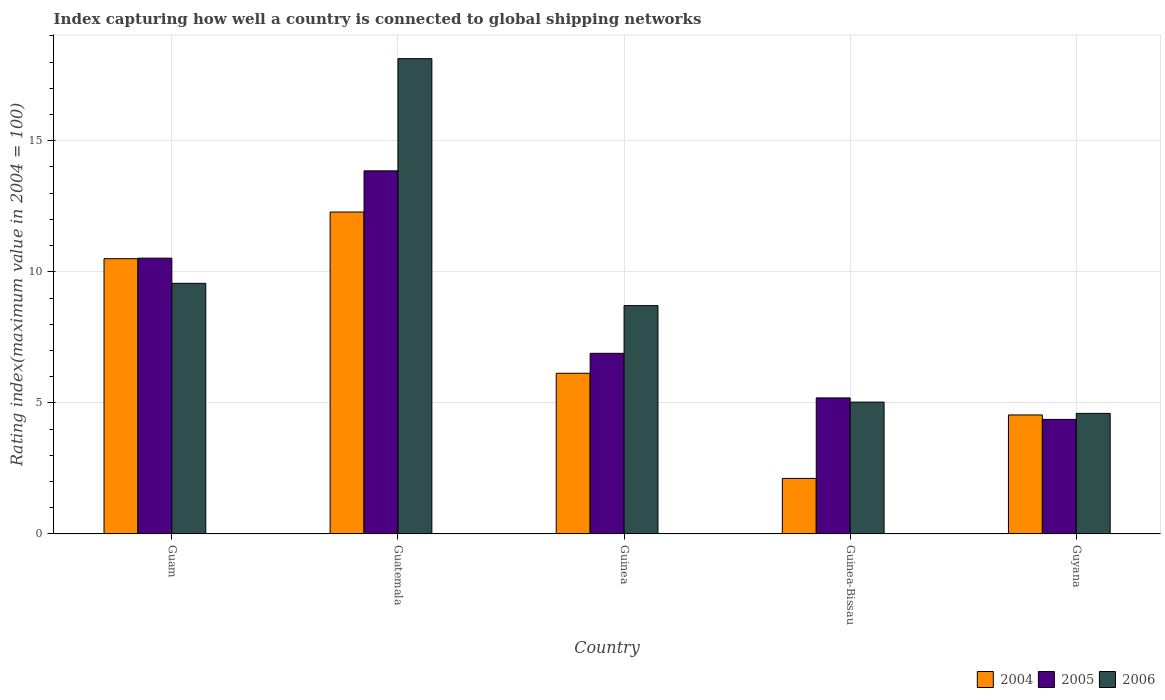How many groups of bars are there?
Keep it short and to the point. 5. How many bars are there on the 5th tick from the left?
Offer a terse response. 3. How many bars are there on the 5th tick from the right?
Provide a succinct answer. 3. What is the label of the 2nd group of bars from the left?
Offer a very short reply. Guatemala. What is the rating index in 2005 in Guam?
Keep it short and to the point. 10.52. Across all countries, what is the maximum rating index in 2005?
Offer a terse response. 13.85. Across all countries, what is the minimum rating index in 2004?
Ensure brevity in your answer.  2.12. In which country was the rating index in 2004 maximum?
Provide a succinct answer. Guatemala. In which country was the rating index in 2005 minimum?
Your response must be concise. Guyana. What is the total rating index in 2004 in the graph?
Your response must be concise. 35.57. What is the difference between the rating index in 2004 in Guatemala and that in Guinea-Bissau?
Ensure brevity in your answer.  10.16. What is the difference between the rating index in 2004 in Guam and the rating index in 2006 in Guyana?
Your answer should be very brief. 5.9. What is the average rating index in 2006 per country?
Ensure brevity in your answer.  9.21. What is the difference between the rating index of/in 2004 and rating index of/in 2005 in Guinea?
Keep it short and to the point. -0.76. In how many countries, is the rating index in 2006 greater than 8?
Keep it short and to the point. 3. What is the ratio of the rating index in 2005 in Guam to that in Guinea-Bissau?
Offer a very short reply. 2.03. What is the difference between the highest and the second highest rating index in 2006?
Your response must be concise. -0.85. What is the difference between the highest and the lowest rating index in 2005?
Ensure brevity in your answer.  9.48. Is the sum of the rating index in 2004 in Guam and Guinea-Bissau greater than the maximum rating index in 2006 across all countries?
Provide a succinct answer. No. What does the 1st bar from the right in Guatemala represents?
Your answer should be very brief. 2006. How many bars are there?
Provide a succinct answer. 15. How many countries are there in the graph?
Ensure brevity in your answer.  5. Are the values on the major ticks of Y-axis written in scientific E-notation?
Offer a terse response. No. Does the graph contain grids?
Offer a terse response. Yes. How many legend labels are there?
Provide a succinct answer. 3. What is the title of the graph?
Offer a terse response. Index capturing how well a country is connected to global shipping networks. What is the label or title of the Y-axis?
Your answer should be compact. Rating index(maximum value in 2004 = 100). What is the Rating index(maximum value in 2004 = 100) of 2004 in Guam?
Give a very brief answer. 10.5. What is the Rating index(maximum value in 2004 = 100) in 2005 in Guam?
Ensure brevity in your answer.  10.52. What is the Rating index(maximum value in 2004 = 100) in 2006 in Guam?
Provide a short and direct response. 9.56. What is the Rating index(maximum value in 2004 = 100) of 2004 in Guatemala?
Give a very brief answer. 12.28. What is the Rating index(maximum value in 2004 = 100) of 2005 in Guatemala?
Offer a very short reply. 13.85. What is the Rating index(maximum value in 2004 = 100) in 2006 in Guatemala?
Make the answer very short. 18.13. What is the Rating index(maximum value in 2004 = 100) of 2004 in Guinea?
Give a very brief answer. 6.13. What is the Rating index(maximum value in 2004 = 100) in 2005 in Guinea?
Keep it short and to the point. 6.89. What is the Rating index(maximum value in 2004 = 100) of 2006 in Guinea?
Your answer should be compact. 8.71. What is the Rating index(maximum value in 2004 = 100) in 2004 in Guinea-Bissau?
Your answer should be compact. 2.12. What is the Rating index(maximum value in 2004 = 100) in 2005 in Guinea-Bissau?
Your answer should be very brief. 5.19. What is the Rating index(maximum value in 2004 = 100) in 2006 in Guinea-Bissau?
Provide a short and direct response. 5.03. What is the Rating index(maximum value in 2004 = 100) of 2004 in Guyana?
Provide a short and direct response. 4.54. What is the Rating index(maximum value in 2004 = 100) of 2005 in Guyana?
Provide a short and direct response. 4.37. What is the Rating index(maximum value in 2004 = 100) of 2006 in Guyana?
Provide a succinct answer. 4.6. Across all countries, what is the maximum Rating index(maximum value in 2004 = 100) of 2004?
Your response must be concise. 12.28. Across all countries, what is the maximum Rating index(maximum value in 2004 = 100) in 2005?
Ensure brevity in your answer.  13.85. Across all countries, what is the maximum Rating index(maximum value in 2004 = 100) in 2006?
Ensure brevity in your answer.  18.13. Across all countries, what is the minimum Rating index(maximum value in 2004 = 100) of 2004?
Your answer should be compact. 2.12. Across all countries, what is the minimum Rating index(maximum value in 2004 = 100) of 2005?
Your answer should be compact. 4.37. Across all countries, what is the minimum Rating index(maximum value in 2004 = 100) in 2006?
Make the answer very short. 4.6. What is the total Rating index(maximum value in 2004 = 100) in 2004 in the graph?
Provide a succinct answer. 35.57. What is the total Rating index(maximum value in 2004 = 100) of 2005 in the graph?
Your answer should be compact. 40.82. What is the total Rating index(maximum value in 2004 = 100) of 2006 in the graph?
Ensure brevity in your answer.  46.03. What is the difference between the Rating index(maximum value in 2004 = 100) in 2004 in Guam and that in Guatemala?
Make the answer very short. -1.78. What is the difference between the Rating index(maximum value in 2004 = 100) of 2005 in Guam and that in Guatemala?
Offer a very short reply. -3.33. What is the difference between the Rating index(maximum value in 2004 = 100) in 2006 in Guam and that in Guatemala?
Your answer should be very brief. -8.57. What is the difference between the Rating index(maximum value in 2004 = 100) in 2004 in Guam and that in Guinea?
Provide a short and direct response. 4.37. What is the difference between the Rating index(maximum value in 2004 = 100) in 2005 in Guam and that in Guinea?
Offer a very short reply. 3.63. What is the difference between the Rating index(maximum value in 2004 = 100) of 2006 in Guam and that in Guinea?
Offer a terse response. 0.85. What is the difference between the Rating index(maximum value in 2004 = 100) in 2004 in Guam and that in Guinea-Bissau?
Your answer should be very brief. 8.38. What is the difference between the Rating index(maximum value in 2004 = 100) of 2005 in Guam and that in Guinea-Bissau?
Your answer should be very brief. 5.33. What is the difference between the Rating index(maximum value in 2004 = 100) in 2006 in Guam and that in Guinea-Bissau?
Your answer should be very brief. 4.53. What is the difference between the Rating index(maximum value in 2004 = 100) in 2004 in Guam and that in Guyana?
Offer a terse response. 5.96. What is the difference between the Rating index(maximum value in 2004 = 100) of 2005 in Guam and that in Guyana?
Keep it short and to the point. 6.15. What is the difference between the Rating index(maximum value in 2004 = 100) in 2006 in Guam and that in Guyana?
Your answer should be very brief. 4.96. What is the difference between the Rating index(maximum value in 2004 = 100) in 2004 in Guatemala and that in Guinea?
Your answer should be compact. 6.15. What is the difference between the Rating index(maximum value in 2004 = 100) of 2005 in Guatemala and that in Guinea?
Provide a short and direct response. 6.96. What is the difference between the Rating index(maximum value in 2004 = 100) of 2006 in Guatemala and that in Guinea?
Offer a very short reply. 9.42. What is the difference between the Rating index(maximum value in 2004 = 100) in 2004 in Guatemala and that in Guinea-Bissau?
Give a very brief answer. 10.16. What is the difference between the Rating index(maximum value in 2004 = 100) in 2005 in Guatemala and that in Guinea-Bissau?
Keep it short and to the point. 8.66. What is the difference between the Rating index(maximum value in 2004 = 100) of 2004 in Guatemala and that in Guyana?
Your answer should be very brief. 7.74. What is the difference between the Rating index(maximum value in 2004 = 100) of 2005 in Guatemala and that in Guyana?
Offer a terse response. 9.48. What is the difference between the Rating index(maximum value in 2004 = 100) of 2006 in Guatemala and that in Guyana?
Give a very brief answer. 13.53. What is the difference between the Rating index(maximum value in 2004 = 100) of 2004 in Guinea and that in Guinea-Bissau?
Offer a very short reply. 4.01. What is the difference between the Rating index(maximum value in 2004 = 100) in 2006 in Guinea and that in Guinea-Bissau?
Keep it short and to the point. 3.68. What is the difference between the Rating index(maximum value in 2004 = 100) in 2004 in Guinea and that in Guyana?
Your response must be concise. 1.59. What is the difference between the Rating index(maximum value in 2004 = 100) in 2005 in Guinea and that in Guyana?
Your answer should be compact. 2.52. What is the difference between the Rating index(maximum value in 2004 = 100) of 2006 in Guinea and that in Guyana?
Your response must be concise. 4.11. What is the difference between the Rating index(maximum value in 2004 = 100) in 2004 in Guinea-Bissau and that in Guyana?
Your response must be concise. -2.42. What is the difference between the Rating index(maximum value in 2004 = 100) of 2005 in Guinea-Bissau and that in Guyana?
Ensure brevity in your answer.  0.82. What is the difference between the Rating index(maximum value in 2004 = 100) of 2006 in Guinea-Bissau and that in Guyana?
Provide a succinct answer. 0.43. What is the difference between the Rating index(maximum value in 2004 = 100) in 2004 in Guam and the Rating index(maximum value in 2004 = 100) in 2005 in Guatemala?
Give a very brief answer. -3.35. What is the difference between the Rating index(maximum value in 2004 = 100) of 2004 in Guam and the Rating index(maximum value in 2004 = 100) of 2006 in Guatemala?
Make the answer very short. -7.63. What is the difference between the Rating index(maximum value in 2004 = 100) of 2005 in Guam and the Rating index(maximum value in 2004 = 100) of 2006 in Guatemala?
Offer a terse response. -7.61. What is the difference between the Rating index(maximum value in 2004 = 100) of 2004 in Guam and the Rating index(maximum value in 2004 = 100) of 2005 in Guinea?
Provide a succinct answer. 3.61. What is the difference between the Rating index(maximum value in 2004 = 100) in 2004 in Guam and the Rating index(maximum value in 2004 = 100) in 2006 in Guinea?
Provide a short and direct response. 1.79. What is the difference between the Rating index(maximum value in 2004 = 100) of 2005 in Guam and the Rating index(maximum value in 2004 = 100) of 2006 in Guinea?
Keep it short and to the point. 1.81. What is the difference between the Rating index(maximum value in 2004 = 100) in 2004 in Guam and the Rating index(maximum value in 2004 = 100) in 2005 in Guinea-Bissau?
Provide a short and direct response. 5.31. What is the difference between the Rating index(maximum value in 2004 = 100) of 2004 in Guam and the Rating index(maximum value in 2004 = 100) of 2006 in Guinea-Bissau?
Your answer should be compact. 5.47. What is the difference between the Rating index(maximum value in 2004 = 100) of 2005 in Guam and the Rating index(maximum value in 2004 = 100) of 2006 in Guinea-Bissau?
Your answer should be compact. 5.49. What is the difference between the Rating index(maximum value in 2004 = 100) in 2004 in Guam and the Rating index(maximum value in 2004 = 100) in 2005 in Guyana?
Make the answer very short. 6.13. What is the difference between the Rating index(maximum value in 2004 = 100) in 2004 in Guam and the Rating index(maximum value in 2004 = 100) in 2006 in Guyana?
Offer a very short reply. 5.9. What is the difference between the Rating index(maximum value in 2004 = 100) of 2005 in Guam and the Rating index(maximum value in 2004 = 100) of 2006 in Guyana?
Make the answer very short. 5.92. What is the difference between the Rating index(maximum value in 2004 = 100) of 2004 in Guatemala and the Rating index(maximum value in 2004 = 100) of 2005 in Guinea?
Offer a very short reply. 5.39. What is the difference between the Rating index(maximum value in 2004 = 100) in 2004 in Guatemala and the Rating index(maximum value in 2004 = 100) in 2006 in Guinea?
Provide a short and direct response. 3.57. What is the difference between the Rating index(maximum value in 2004 = 100) of 2005 in Guatemala and the Rating index(maximum value in 2004 = 100) of 2006 in Guinea?
Ensure brevity in your answer.  5.14. What is the difference between the Rating index(maximum value in 2004 = 100) in 2004 in Guatemala and the Rating index(maximum value in 2004 = 100) in 2005 in Guinea-Bissau?
Give a very brief answer. 7.09. What is the difference between the Rating index(maximum value in 2004 = 100) of 2004 in Guatemala and the Rating index(maximum value in 2004 = 100) of 2006 in Guinea-Bissau?
Provide a succinct answer. 7.25. What is the difference between the Rating index(maximum value in 2004 = 100) of 2005 in Guatemala and the Rating index(maximum value in 2004 = 100) of 2006 in Guinea-Bissau?
Offer a terse response. 8.82. What is the difference between the Rating index(maximum value in 2004 = 100) in 2004 in Guatemala and the Rating index(maximum value in 2004 = 100) in 2005 in Guyana?
Offer a terse response. 7.91. What is the difference between the Rating index(maximum value in 2004 = 100) in 2004 in Guatemala and the Rating index(maximum value in 2004 = 100) in 2006 in Guyana?
Provide a short and direct response. 7.68. What is the difference between the Rating index(maximum value in 2004 = 100) of 2005 in Guatemala and the Rating index(maximum value in 2004 = 100) of 2006 in Guyana?
Give a very brief answer. 9.25. What is the difference between the Rating index(maximum value in 2004 = 100) of 2004 in Guinea and the Rating index(maximum value in 2004 = 100) of 2005 in Guinea-Bissau?
Your response must be concise. 0.94. What is the difference between the Rating index(maximum value in 2004 = 100) in 2004 in Guinea and the Rating index(maximum value in 2004 = 100) in 2006 in Guinea-Bissau?
Provide a succinct answer. 1.1. What is the difference between the Rating index(maximum value in 2004 = 100) in 2005 in Guinea and the Rating index(maximum value in 2004 = 100) in 2006 in Guinea-Bissau?
Your response must be concise. 1.86. What is the difference between the Rating index(maximum value in 2004 = 100) of 2004 in Guinea and the Rating index(maximum value in 2004 = 100) of 2005 in Guyana?
Offer a terse response. 1.76. What is the difference between the Rating index(maximum value in 2004 = 100) in 2004 in Guinea and the Rating index(maximum value in 2004 = 100) in 2006 in Guyana?
Offer a very short reply. 1.53. What is the difference between the Rating index(maximum value in 2004 = 100) of 2005 in Guinea and the Rating index(maximum value in 2004 = 100) of 2006 in Guyana?
Make the answer very short. 2.29. What is the difference between the Rating index(maximum value in 2004 = 100) in 2004 in Guinea-Bissau and the Rating index(maximum value in 2004 = 100) in 2005 in Guyana?
Provide a short and direct response. -2.25. What is the difference between the Rating index(maximum value in 2004 = 100) of 2004 in Guinea-Bissau and the Rating index(maximum value in 2004 = 100) of 2006 in Guyana?
Give a very brief answer. -2.48. What is the difference between the Rating index(maximum value in 2004 = 100) of 2005 in Guinea-Bissau and the Rating index(maximum value in 2004 = 100) of 2006 in Guyana?
Keep it short and to the point. 0.59. What is the average Rating index(maximum value in 2004 = 100) in 2004 per country?
Make the answer very short. 7.11. What is the average Rating index(maximum value in 2004 = 100) of 2005 per country?
Offer a terse response. 8.16. What is the average Rating index(maximum value in 2004 = 100) of 2006 per country?
Make the answer very short. 9.21. What is the difference between the Rating index(maximum value in 2004 = 100) in 2004 and Rating index(maximum value in 2004 = 100) in 2005 in Guam?
Offer a very short reply. -0.02. What is the difference between the Rating index(maximum value in 2004 = 100) of 2004 and Rating index(maximum value in 2004 = 100) of 2006 in Guam?
Provide a short and direct response. 0.94. What is the difference between the Rating index(maximum value in 2004 = 100) in 2005 and Rating index(maximum value in 2004 = 100) in 2006 in Guam?
Offer a very short reply. 0.96. What is the difference between the Rating index(maximum value in 2004 = 100) in 2004 and Rating index(maximum value in 2004 = 100) in 2005 in Guatemala?
Provide a succinct answer. -1.57. What is the difference between the Rating index(maximum value in 2004 = 100) in 2004 and Rating index(maximum value in 2004 = 100) in 2006 in Guatemala?
Give a very brief answer. -5.85. What is the difference between the Rating index(maximum value in 2004 = 100) of 2005 and Rating index(maximum value in 2004 = 100) of 2006 in Guatemala?
Offer a very short reply. -4.28. What is the difference between the Rating index(maximum value in 2004 = 100) of 2004 and Rating index(maximum value in 2004 = 100) of 2005 in Guinea?
Your response must be concise. -0.76. What is the difference between the Rating index(maximum value in 2004 = 100) of 2004 and Rating index(maximum value in 2004 = 100) of 2006 in Guinea?
Offer a terse response. -2.58. What is the difference between the Rating index(maximum value in 2004 = 100) of 2005 and Rating index(maximum value in 2004 = 100) of 2006 in Guinea?
Provide a short and direct response. -1.82. What is the difference between the Rating index(maximum value in 2004 = 100) of 2004 and Rating index(maximum value in 2004 = 100) of 2005 in Guinea-Bissau?
Your answer should be compact. -3.07. What is the difference between the Rating index(maximum value in 2004 = 100) in 2004 and Rating index(maximum value in 2004 = 100) in 2006 in Guinea-Bissau?
Keep it short and to the point. -2.91. What is the difference between the Rating index(maximum value in 2004 = 100) in 2005 and Rating index(maximum value in 2004 = 100) in 2006 in Guinea-Bissau?
Give a very brief answer. 0.16. What is the difference between the Rating index(maximum value in 2004 = 100) in 2004 and Rating index(maximum value in 2004 = 100) in 2005 in Guyana?
Your response must be concise. 0.17. What is the difference between the Rating index(maximum value in 2004 = 100) of 2004 and Rating index(maximum value in 2004 = 100) of 2006 in Guyana?
Provide a succinct answer. -0.06. What is the difference between the Rating index(maximum value in 2004 = 100) of 2005 and Rating index(maximum value in 2004 = 100) of 2006 in Guyana?
Offer a terse response. -0.23. What is the ratio of the Rating index(maximum value in 2004 = 100) in 2004 in Guam to that in Guatemala?
Ensure brevity in your answer.  0.85. What is the ratio of the Rating index(maximum value in 2004 = 100) in 2005 in Guam to that in Guatemala?
Keep it short and to the point. 0.76. What is the ratio of the Rating index(maximum value in 2004 = 100) in 2006 in Guam to that in Guatemala?
Offer a terse response. 0.53. What is the ratio of the Rating index(maximum value in 2004 = 100) in 2004 in Guam to that in Guinea?
Ensure brevity in your answer.  1.71. What is the ratio of the Rating index(maximum value in 2004 = 100) in 2005 in Guam to that in Guinea?
Give a very brief answer. 1.53. What is the ratio of the Rating index(maximum value in 2004 = 100) of 2006 in Guam to that in Guinea?
Keep it short and to the point. 1.1. What is the ratio of the Rating index(maximum value in 2004 = 100) of 2004 in Guam to that in Guinea-Bissau?
Provide a succinct answer. 4.95. What is the ratio of the Rating index(maximum value in 2004 = 100) of 2005 in Guam to that in Guinea-Bissau?
Your answer should be very brief. 2.03. What is the ratio of the Rating index(maximum value in 2004 = 100) of 2006 in Guam to that in Guinea-Bissau?
Your answer should be very brief. 1.9. What is the ratio of the Rating index(maximum value in 2004 = 100) of 2004 in Guam to that in Guyana?
Your response must be concise. 2.31. What is the ratio of the Rating index(maximum value in 2004 = 100) of 2005 in Guam to that in Guyana?
Your response must be concise. 2.41. What is the ratio of the Rating index(maximum value in 2004 = 100) of 2006 in Guam to that in Guyana?
Give a very brief answer. 2.08. What is the ratio of the Rating index(maximum value in 2004 = 100) in 2004 in Guatemala to that in Guinea?
Offer a terse response. 2. What is the ratio of the Rating index(maximum value in 2004 = 100) in 2005 in Guatemala to that in Guinea?
Provide a succinct answer. 2.01. What is the ratio of the Rating index(maximum value in 2004 = 100) of 2006 in Guatemala to that in Guinea?
Offer a terse response. 2.08. What is the ratio of the Rating index(maximum value in 2004 = 100) in 2004 in Guatemala to that in Guinea-Bissau?
Provide a succinct answer. 5.79. What is the ratio of the Rating index(maximum value in 2004 = 100) in 2005 in Guatemala to that in Guinea-Bissau?
Provide a succinct answer. 2.67. What is the ratio of the Rating index(maximum value in 2004 = 100) of 2006 in Guatemala to that in Guinea-Bissau?
Provide a succinct answer. 3.6. What is the ratio of the Rating index(maximum value in 2004 = 100) in 2004 in Guatemala to that in Guyana?
Provide a short and direct response. 2.7. What is the ratio of the Rating index(maximum value in 2004 = 100) of 2005 in Guatemala to that in Guyana?
Offer a very short reply. 3.17. What is the ratio of the Rating index(maximum value in 2004 = 100) of 2006 in Guatemala to that in Guyana?
Give a very brief answer. 3.94. What is the ratio of the Rating index(maximum value in 2004 = 100) in 2004 in Guinea to that in Guinea-Bissau?
Your answer should be very brief. 2.89. What is the ratio of the Rating index(maximum value in 2004 = 100) in 2005 in Guinea to that in Guinea-Bissau?
Provide a short and direct response. 1.33. What is the ratio of the Rating index(maximum value in 2004 = 100) of 2006 in Guinea to that in Guinea-Bissau?
Your answer should be compact. 1.73. What is the ratio of the Rating index(maximum value in 2004 = 100) of 2004 in Guinea to that in Guyana?
Your answer should be very brief. 1.35. What is the ratio of the Rating index(maximum value in 2004 = 100) in 2005 in Guinea to that in Guyana?
Offer a terse response. 1.58. What is the ratio of the Rating index(maximum value in 2004 = 100) in 2006 in Guinea to that in Guyana?
Offer a terse response. 1.89. What is the ratio of the Rating index(maximum value in 2004 = 100) in 2004 in Guinea-Bissau to that in Guyana?
Your answer should be compact. 0.47. What is the ratio of the Rating index(maximum value in 2004 = 100) of 2005 in Guinea-Bissau to that in Guyana?
Provide a succinct answer. 1.19. What is the ratio of the Rating index(maximum value in 2004 = 100) in 2006 in Guinea-Bissau to that in Guyana?
Ensure brevity in your answer.  1.09. What is the difference between the highest and the second highest Rating index(maximum value in 2004 = 100) in 2004?
Provide a short and direct response. 1.78. What is the difference between the highest and the second highest Rating index(maximum value in 2004 = 100) of 2005?
Your answer should be very brief. 3.33. What is the difference between the highest and the second highest Rating index(maximum value in 2004 = 100) in 2006?
Offer a terse response. 8.57. What is the difference between the highest and the lowest Rating index(maximum value in 2004 = 100) of 2004?
Offer a terse response. 10.16. What is the difference between the highest and the lowest Rating index(maximum value in 2004 = 100) in 2005?
Your answer should be very brief. 9.48. What is the difference between the highest and the lowest Rating index(maximum value in 2004 = 100) in 2006?
Provide a short and direct response. 13.53. 